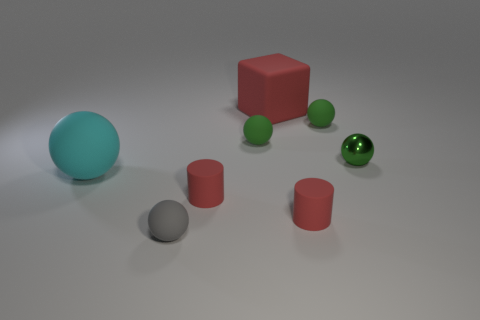What is the cyan sphere made of?
Offer a very short reply. Rubber. Are there any small green metallic balls in front of the cube?
Make the answer very short. Yes. Is the shape of the big cyan thing the same as the large red thing?
Ensure brevity in your answer.  No. What number of other objects are the same size as the rubber cube?
Make the answer very short. 1. How many things are tiny spheres that are on the left side of the big red thing or cubes?
Your response must be concise. 3. The big cube has what color?
Provide a short and direct response. Red. Does the shiny thing have the same shape as the cyan rubber object that is behind the tiny gray matte sphere?
Provide a short and direct response. Yes. Is the number of blue cylinders greater than the number of tiny red matte cylinders?
Make the answer very short. No. Are there any other things of the same color as the matte cube?
Keep it short and to the point. Yes. There is a large object that is the same material as the large sphere; what shape is it?
Your response must be concise. Cube. 